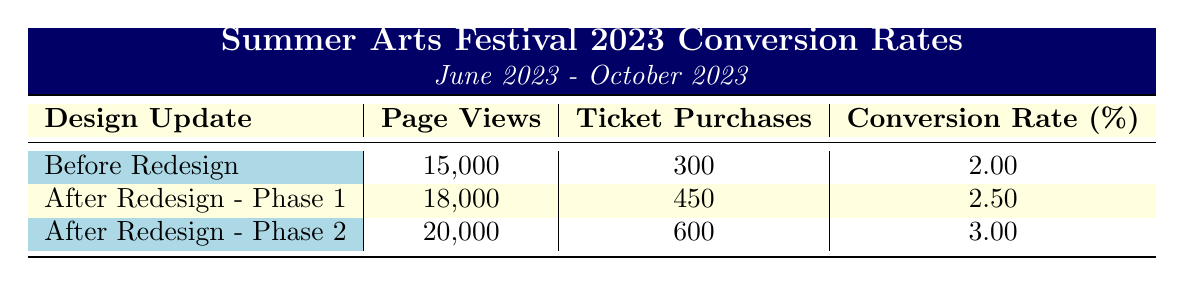What was the conversion rate before the redesign? According to the table, the conversion rate listed under "Before Redesign" is 2.00%.
Answer: 2.00% How many ticket purchases were made after the Phase 1 redesign? The table indicates that after the "After Redesign - Phase 1," there were 450 ticket purchases.
Answer: 450 What is the difference in ticket purchases between Phase 1 and Phase 2 of the redesign? The ticket purchases for Phase 1 are 450 and for Phase 2 are 600. The difference is calculated as 600 - 450 = 150.
Answer: 150 Did the conversion rate increase after the redesign? By comparing the "Before Redesign" conversion rate of 2.00% with the "After Redesign - Phase 1" rate of 2.50% and the "After Redesign - Phase 2" rate of 3.00%, we can see that both post-redesign rates are higher.
Answer: Yes What is the total number of page views for all redesign phases combined? The total page views are calculated by summing the page views for all three redesign entries: 15000 + 18000 + 20000 = 53000.
Answer: 53000 What is the average conversion rate across all design updates? To find the average conversion rate, we sum the conversion rates (2.00 + 2.50 + 3.00 = 7.50) and divide by the number of phases (3). This gives us 7.50 / 3 = 2.50%.
Answer: 2.50% How many total ticket purchases were made during the entire listed period? We sum the ticket purchases: 300 (Before Redesign) + 450 (After Redesign - Phase 1) + 600 (After Redesign - Phase 2) = 1350 total ticket purchases.
Answer: 1350 Which design update had the highest conversion rate? The table shows that "After Redesign - Phase 2" had the highest conversion rate at 3.00%.
Answer: After Redesign - Phase 2 What was the page view increase from before the redesign to after Phase 2? Before Redesign had 15000 page views, and after Phase 2 there were 20000 page views. The increase is calculated as 20000 - 15000 = 5000 page views.
Answer: 5000 